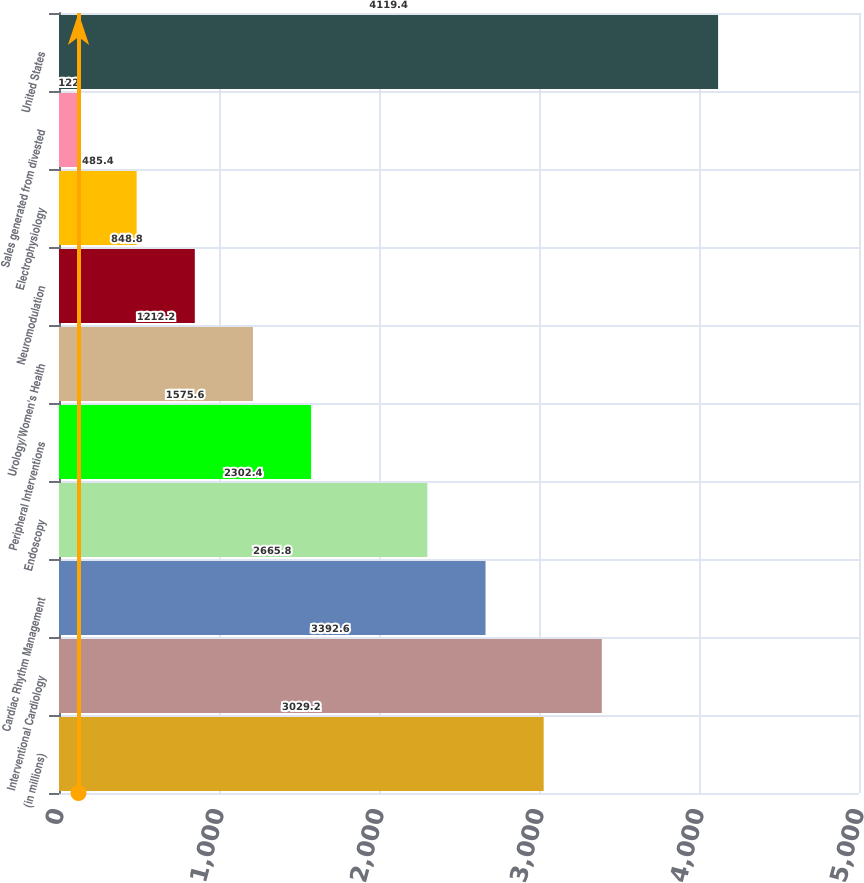<chart> <loc_0><loc_0><loc_500><loc_500><bar_chart><fcel>(in millions)<fcel>Interventional Cardiology<fcel>Cardiac Rhythm Management<fcel>Endoscopy<fcel>Peripheral Interventions<fcel>Urology/Women's Health<fcel>Neuromodulation<fcel>Electrophysiology<fcel>Sales generated from divested<fcel>United States<nl><fcel>3029.2<fcel>3392.6<fcel>2665.8<fcel>2302.4<fcel>1575.6<fcel>1212.2<fcel>848.8<fcel>485.4<fcel>122<fcel>4119.4<nl></chart> 